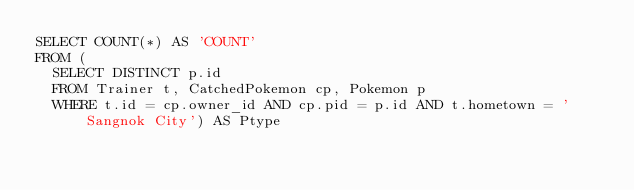<code> <loc_0><loc_0><loc_500><loc_500><_SQL_>SELECT COUNT(*) AS 'COUNT'
FROM (
  SELECT DISTINCT p.id
  FROM Trainer t, CatchedPokemon cp, Pokemon p
  WHERE t.id = cp.owner_id AND cp.pid = p.id AND t.hometown = 'Sangnok City') AS Ptype</code> 